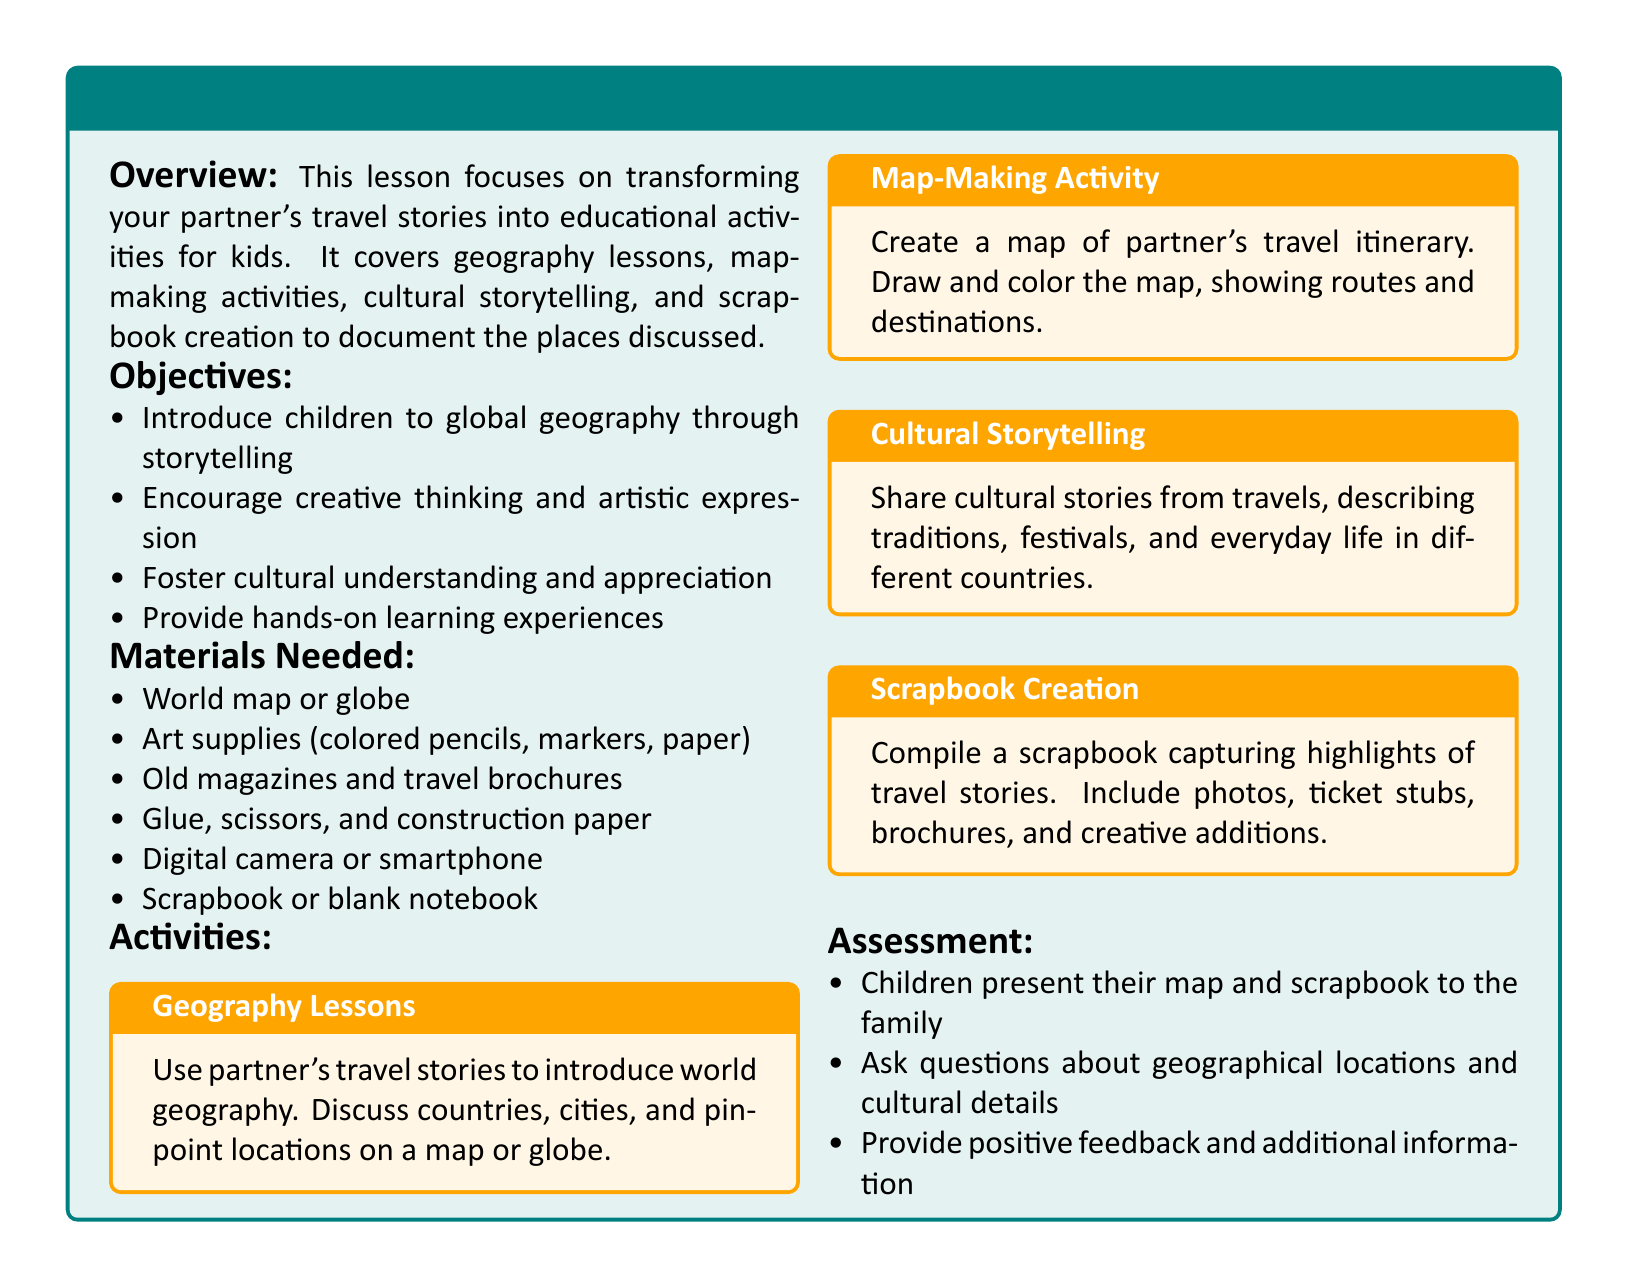what is the title of the lesson plan? The title of the lesson plan is stated at the beginning, which highlights the focus on travel stories and learning.
Answer: Travel Stories: Turning Your Partner's Adventures into Learning how many objectives are listed in the lesson plan? The lesson plan provides a list of objectives, which can be counted directly from the text.
Answer: Four what activity involves creating a visual representation of partner's travel itinerary? The lesson plan specifies an activity dedicated to mapping out travel plans, indicating its focus on creativity.
Answer: Map-Making Activity what materials are required for scrapbook creation? The lesson mentions specific items needed for the scrapbook, which can be directly retrieved.
Answer: Photos, ticket stubs, brochures, and creative additions which educational aspect is emphasized through storytelling? The lesson plan indicates the primary educational focus aimed by the activities is linked to global understanding through narratives.
Answer: Geography what is the method of assessment suggested in the lesson plan? The lesson plan outlines a way to evaluate children's learning through interactive presentations and discussions.
Answer: Presenting their map and scrapbook to the family what type of cultural aspects are shared in the storytelling activity? The specific cultural details to be discussed are highlighted in the context of the storytelling activity described.
Answer: Traditions, festivals, and everyday life what color represents the geography lessons section? The document uses specific color coding for different sections, which can be identified from the text.
Answer: Second color (orange) 